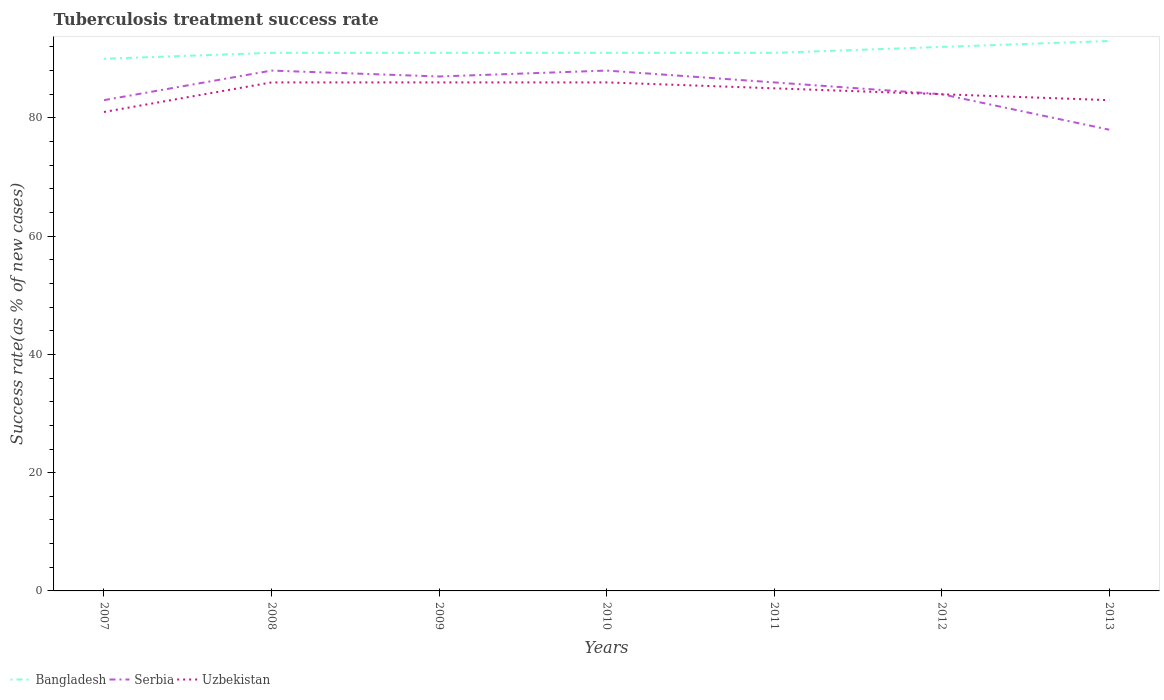What is the difference between the highest and the second highest tuberculosis treatment success rate in Uzbekistan?
Give a very brief answer. 5. Is the tuberculosis treatment success rate in Serbia strictly greater than the tuberculosis treatment success rate in Bangladesh over the years?
Provide a succinct answer. Yes. How many years are there in the graph?
Provide a short and direct response. 7. Does the graph contain any zero values?
Ensure brevity in your answer.  No. How many legend labels are there?
Provide a short and direct response. 3. What is the title of the graph?
Provide a short and direct response. Tuberculosis treatment success rate. What is the label or title of the Y-axis?
Make the answer very short. Success rate(as % of new cases). What is the Success rate(as % of new cases) in Bangladesh in 2007?
Offer a very short reply. 90. What is the Success rate(as % of new cases) in Bangladesh in 2008?
Your answer should be very brief. 91. What is the Success rate(as % of new cases) of Uzbekistan in 2008?
Your response must be concise. 86. What is the Success rate(as % of new cases) of Bangladesh in 2009?
Ensure brevity in your answer.  91. What is the Success rate(as % of new cases) in Serbia in 2009?
Offer a very short reply. 87. What is the Success rate(as % of new cases) of Uzbekistan in 2009?
Ensure brevity in your answer.  86. What is the Success rate(as % of new cases) of Bangladesh in 2010?
Provide a short and direct response. 91. What is the Success rate(as % of new cases) of Serbia in 2010?
Your answer should be compact. 88. What is the Success rate(as % of new cases) in Uzbekistan in 2010?
Provide a short and direct response. 86. What is the Success rate(as % of new cases) in Bangladesh in 2011?
Ensure brevity in your answer.  91. What is the Success rate(as % of new cases) in Serbia in 2011?
Make the answer very short. 86. What is the Success rate(as % of new cases) in Bangladesh in 2012?
Your answer should be compact. 92. What is the Success rate(as % of new cases) in Serbia in 2012?
Make the answer very short. 84. What is the Success rate(as % of new cases) of Bangladesh in 2013?
Keep it short and to the point. 93. What is the Success rate(as % of new cases) in Uzbekistan in 2013?
Offer a terse response. 83. Across all years, what is the maximum Success rate(as % of new cases) in Bangladesh?
Offer a terse response. 93. Across all years, what is the maximum Success rate(as % of new cases) of Uzbekistan?
Ensure brevity in your answer.  86. Across all years, what is the minimum Success rate(as % of new cases) of Bangladesh?
Your response must be concise. 90. Across all years, what is the minimum Success rate(as % of new cases) in Serbia?
Provide a short and direct response. 78. Across all years, what is the minimum Success rate(as % of new cases) of Uzbekistan?
Offer a terse response. 81. What is the total Success rate(as % of new cases) in Bangladesh in the graph?
Ensure brevity in your answer.  639. What is the total Success rate(as % of new cases) of Serbia in the graph?
Your answer should be very brief. 594. What is the total Success rate(as % of new cases) in Uzbekistan in the graph?
Give a very brief answer. 591. What is the difference between the Success rate(as % of new cases) in Bangladesh in 2007 and that in 2008?
Make the answer very short. -1. What is the difference between the Success rate(as % of new cases) of Uzbekistan in 2007 and that in 2008?
Make the answer very short. -5. What is the difference between the Success rate(as % of new cases) of Serbia in 2007 and that in 2009?
Your response must be concise. -4. What is the difference between the Success rate(as % of new cases) of Uzbekistan in 2007 and that in 2010?
Provide a succinct answer. -5. What is the difference between the Success rate(as % of new cases) of Serbia in 2007 and that in 2012?
Keep it short and to the point. -1. What is the difference between the Success rate(as % of new cases) in Uzbekistan in 2007 and that in 2012?
Provide a short and direct response. -3. What is the difference between the Success rate(as % of new cases) of Bangladesh in 2007 and that in 2013?
Provide a succinct answer. -3. What is the difference between the Success rate(as % of new cases) in Bangladesh in 2008 and that in 2010?
Keep it short and to the point. 0. What is the difference between the Success rate(as % of new cases) of Bangladesh in 2008 and that in 2011?
Your answer should be compact. 0. What is the difference between the Success rate(as % of new cases) in Serbia in 2008 and that in 2011?
Provide a short and direct response. 2. What is the difference between the Success rate(as % of new cases) of Uzbekistan in 2008 and that in 2012?
Give a very brief answer. 2. What is the difference between the Success rate(as % of new cases) of Serbia in 2008 and that in 2013?
Offer a terse response. 10. What is the difference between the Success rate(as % of new cases) in Bangladesh in 2009 and that in 2010?
Provide a short and direct response. 0. What is the difference between the Success rate(as % of new cases) of Bangladesh in 2009 and that in 2012?
Make the answer very short. -1. What is the difference between the Success rate(as % of new cases) in Serbia in 2009 and that in 2012?
Offer a terse response. 3. What is the difference between the Success rate(as % of new cases) of Bangladesh in 2009 and that in 2013?
Offer a terse response. -2. What is the difference between the Success rate(as % of new cases) in Serbia in 2009 and that in 2013?
Your answer should be compact. 9. What is the difference between the Success rate(as % of new cases) of Uzbekistan in 2009 and that in 2013?
Provide a short and direct response. 3. What is the difference between the Success rate(as % of new cases) of Serbia in 2010 and that in 2011?
Provide a succinct answer. 2. What is the difference between the Success rate(as % of new cases) of Bangladesh in 2010 and that in 2012?
Your response must be concise. -1. What is the difference between the Success rate(as % of new cases) of Serbia in 2010 and that in 2013?
Your answer should be compact. 10. What is the difference between the Success rate(as % of new cases) in Uzbekistan in 2010 and that in 2013?
Your answer should be very brief. 3. What is the difference between the Success rate(as % of new cases) in Bangladesh in 2011 and that in 2012?
Keep it short and to the point. -1. What is the difference between the Success rate(as % of new cases) in Serbia in 2011 and that in 2012?
Provide a succinct answer. 2. What is the difference between the Success rate(as % of new cases) in Serbia in 2011 and that in 2013?
Your answer should be very brief. 8. What is the difference between the Success rate(as % of new cases) in Bangladesh in 2012 and that in 2013?
Your answer should be compact. -1. What is the difference between the Success rate(as % of new cases) of Serbia in 2012 and that in 2013?
Keep it short and to the point. 6. What is the difference between the Success rate(as % of new cases) of Bangladesh in 2007 and the Success rate(as % of new cases) of Uzbekistan in 2008?
Offer a terse response. 4. What is the difference between the Success rate(as % of new cases) in Bangladesh in 2007 and the Success rate(as % of new cases) in Serbia in 2010?
Provide a short and direct response. 2. What is the difference between the Success rate(as % of new cases) in Bangladesh in 2007 and the Success rate(as % of new cases) in Uzbekistan in 2010?
Keep it short and to the point. 4. What is the difference between the Success rate(as % of new cases) in Serbia in 2007 and the Success rate(as % of new cases) in Uzbekistan in 2010?
Give a very brief answer. -3. What is the difference between the Success rate(as % of new cases) in Serbia in 2007 and the Success rate(as % of new cases) in Uzbekistan in 2012?
Your answer should be very brief. -1. What is the difference between the Success rate(as % of new cases) of Bangladesh in 2007 and the Success rate(as % of new cases) of Serbia in 2013?
Your answer should be very brief. 12. What is the difference between the Success rate(as % of new cases) of Bangladesh in 2007 and the Success rate(as % of new cases) of Uzbekistan in 2013?
Your answer should be very brief. 7. What is the difference between the Success rate(as % of new cases) in Serbia in 2007 and the Success rate(as % of new cases) in Uzbekistan in 2013?
Ensure brevity in your answer.  0. What is the difference between the Success rate(as % of new cases) in Bangladesh in 2008 and the Success rate(as % of new cases) in Uzbekistan in 2009?
Make the answer very short. 5. What is the difference between the Success rate(as % of new cases) of Bangladesh in 2008 and the Success rate(as % of new cases) of Uzbekistan in 2011?
Make the answer very short. 6. What is the difference between the Success rate(as % of new cases) in Bangladesh in 2008 and the Success rate(as % of new cases) in Serbia in 2012?
Offer a terse response. 7. What is the difference between the Success rate(as % of new cases) in Bangladesh in 2008 and the Success rate(as % of new cases) in Serbia in 2013?
Provide a succinct answer. 13. What is the difference between the Success rate(as % of new cases) in Bangladesh in 2008 and the Success rate(as % of new cases) in Uzbekistan in 2013?
Your answer should be compact. 8. What is the difference between the Success rate(as % of new cases) of Serbia in 2009 and the Success rate(as % of new cases) of Uzbekistan in 2011?
Offer a very short reply. 2. What is the difference between the Success rate(as % of new cases) in Bangladesh in 2009 and the Success rate(as % of new cases) in Serbia in 2012?
Give a very brief answer. 7. What is the difference between the Success rate(as % of new cases) in Bangladesh in 2009 and the Success rate(as % of new cases) in Serbia in 2013?
Your answer should be compact. 13. What is the difference between the Success rate(as % of new cases) in Serbia in 2009 and the Success rate(as % of new cases) in Uzbekistan in 2013?
Make the answer very short. 4. What is the difference between the Success rate(as % of new cases) in Serbia in 2010 and the Success rate(as % of new cases) in Uzbekistan in 2011?
Offer a terse response. 3. What is the difference between the Success rate(as % of new cases) in Bangladesh in 2010 and the Success rate(as % of new cases) in Uzbekistan in 2012?
Make the answer very short. 7. What is the difference between the Success rate(as % of new cases) of Serbia in 2010 and the Success rate(as % of new cases) of Uzbekistan in 2013?
Your answer should be very brief. 5. What is the difference between the Success rate(as % of new cases) in Bangladesh in 2011 and the Success rate(as % of new cases) in Serbia in 2012?
Provide a short and direct response. 7. What is the difference between the Success rate(as % of new cases) in Bangladesh in 2011 and the Success rate(as % of new cases) in Serbia in 2013?
Provide a short and direct response. 13. What is the difference between the Success rate(as % of new cases) in Serbia in 2011 and the Success rate(as % of new cases) in Uzbekistan in 2013?
Ensure brevity in your answer.  3. What is the average Success rate(as % of new cases) of Bangladesh per year?
Your answer should be very brief. 91.29. What is the average Success rate(as % of new cases) in Serbia per year?
Your answer should be compact. 84.86. What is the average Success rate(as % of new cases) of Uzbekistan per year?
Provide a succinct answer. 84.43. In the year 2007, what is the difference between the Success rate(as % of new cases) in Bangladesh and Success rate(as % of new cases) in Serbia?
Make the answer very short. 7. In the year 2007, what is the difference between the Success rate(as % of new cases) in Serbia and Success rate(as % of new cases) in Uzbekistan?
Provide a short and direct response. 2. In the year 2008, what is the difference between the Success rate(as % of new cases) of Bangladesh and Success rate(as % of new cases) of Serbia?
Your answer should be compact. 3. In the year 2009, what is the difference between the Success rate(as % of new cases) of Bangladesh and Success rate(as % of new cases) of Uzbekistan?
Ensure brevity in your answer.  5. In the year 2009, what is the difference between the Success rate(as % of new cases) of Serbia and Success rate(as % of new cases) of Uzbekistan?
Offer a very short reply. 1. In the year 2010, what is the difference between the Success rate(as % of new cases) in Bangladesh and Success rate(as % of new cases) in Serbia?
Your response must be concise. 3. In the year 2010, what is the difference between the Success rate(as % of new cases) of Serbia and Success rate(as % of new cases) of Uzbekistan?
Offer a very short reply. 2. In the year 2011, what is the difference between the Success rate(as % of new cases) in Bangladesh and Success rate(as % of new cases) in Serbia?
Offer a very short reply. 5. In the year 2011, what is the difference between the Success rate(as % of new cases) in Bangladesh and Success rate(as % of new cases) in Uzbekistan?
Ensure brevity in your answer.  6. In the year 2011, what is the difference between the Success rate(as % of new cases) in Serbia and Success rate(as % of new cases) in Uzbekistan?
Provide a succinct answer. 1. In the year 2012, what is the difference between the Success rate(as % of new cases) of Bangladesh and Success rate(as % of new cases) of Serbia?
Keep it short and to the point. 8. In the year 2012, what is the difference between the Success rate(as % of new cases) in Serbia and Success rate(as % of new cases) in Uzbekistan?
Offer a very short reply. 0. In the year 2013, what is the difference between the Success rate(as % of new cases) in Bangladesh and Success rate(as % of new cases) in Serbia?
Your answer should be very brief. 15. In the year 2013, what is the difference between the Success rate(as % of new cases) in Bangladesh and Success rate(as % of new cases) in Uzbekistan?
Give a very brief answer. 10. In the year 2013, what is the difference between the Success rate(as % of new cases) in Serbia and Success rate(as % of new cases) in Uzbekistan?
Your response must be concise. -5. What is the ratio of the Success rate(as % of new cases) in Bangladesh in 2007 to that in 2008?
Make the answer very short. 0.99. What is the ratio of the Success rate(as % of new cases) of Serbia in 2007 to that in 2008?
Keep it short and to the point. 0.94. What is the ratio of the Success rate(as % of new cases) of Uzbekistan in 2007 to that in 2008?
Offer a very short reply. 0.94. What is the ratio of the Success rate(as % of new cases) in Serbia in 2007 to that in 2009?
Keep it short and to the point. 0.95. What is the ratio of the Success rate(as % of new cases) in Uzbekistan in 2007 to that in 2009?
Provide a succinct answer. 0.94. What is the ratio of the Success rate(as % of new cases) of Serbia in 2007 to that in 2010?
Make the answer very short. 0.94. What is the ratio of the Success rate(as % of new cases) in Uzbekistan in 2007 to that in 2010?
Keep it short and to the point. 0.94. What is the ratio of the Success rate(as % of new cases) in Serbia in 2007 to that in 2011?
Your answer should be very brief. 0.97. What is the ratio of the Success rate(as % of new cases) in Uzbekistan in 2007 to that in 2011?
Offer a very short reply. 0.95. What is the ratio of the Success rate(as % of new cases) of Bangladesh in 2007 to that in 2012?
Provide a short and direct response. 0.98. What is the ratio of the Success rate(as % of new cases) of Serbia in 2007 to that in 2012?
Give a very brief answer. 0.99. What is the ratio of the Success rate(as % of new cases) in Uzbekistan in 2007 to that in 2012?
Your answer should be compact. 0.96. What is the ratio of the Success rate(as % of new cases) in Serbia in 2007 to that in 2013?
Keep it short and to the point. 1.06. What is the ratio of the Success rate(as % of new cases) of Uzbekistan in 2007 to that in 2013?
Your answer should be very brief. 0.98. What is the ratio of the Success rate(as % of new cases) in Serbia in 2008 to that in 2009?
Your response must be concise. 1.01. What is the ratio of the Success rate(as % of new cases) in Uzbekistan in 2008 to that in 2009?
Your response must be concise. 1. What is the ratio of the Success rate(as % of new cases) of Bangladesh in 2008 to that in 2010?
Provide a succinct answer. 1. What is the ratio of the Success rate(as % of new cases) in Serbia in 2008 to that in 2010?
Your answer should be compact. 1. What is the ratio of the Success rate(as % of new cases) of Bangladesh in 2008 to that in 2011?
Your answer should be compact. 1. What is the ratio of the Success rate(as % of new cases) of Serbia in 2008 to that in 2011?
Offer a terse response. 1.02. What is the ratio of the Success rate(as % of new cases) in Uzbekistan in 2008 to that in 2011?
Offer a terse response. 1.01. What is the ratio of the Success rate(as % of new cases) of Bangladesh in 2008 to that in 2012?
Your answer should be compact. 0.99. What is the ratio of the Success rate(as % of new cases) of Serbia in 2008 to that in 2012?
Ensure brevity in your answer.  1.05. What is the ratio of the Success rate(as % of new cases) of Uzbekistan in 2008 to that in 2012?
Make the answer very short. 1.02. What is the ratio of the Success rate(as % of new cases) of Bangladesh in 2008 to that in 2013?
Ensure brevity in your answer.  0.98. What is the ratio of the Success rate(as % of new cases) in Serbia in 2008 to that in 2013?
Your answer should be very brief. 1.13. What is the ratio of the Success rate(as % of new cases) of Uzbekistan in 2008 to that in 2013?
Provide a short and direct response. 1.04. What is the ratio of the Success rate(as % of new cases) in Serbia in 2009 to that in 2010?
Offer a terse response. 0.99. What is the ratio of the Success rate(as % of new cases) of Serbia in 2009 to that in 2011?
Provide a succinct answer. 1.01. What is the ratio of the Success rate(as % of new cases) of Uzbekistan in 2009 to that in 2011?
Provide a short and direct response. 1.01. What is the ratio of the Success rate(as % of new cases) of Serbia in 2009 to that in 2012?
Offer a terse response. 1.04. What is the ratio of the Success rate(as % of new cases) in Uzbekistan in 2009 to that in 2012?
Ensure brevity in your answer.  1.02. What is the ratio of the Success rate(as % of new cases) in Bangladesh in 2009 to that in 2013?
Offer a terse response. 0.98. What is the ratio of the Success rate(as % of new cases) in Serbia in 2009 to that in 2013?
Give a very brief answer. 1.12. What is the ratio of the Success rate(as % of new cases) of Uzbekistan in 2009 to that in 2013?
Ensure brevity in your answer.  1.04. What is the ratio of the Success rate(as % of new cases) in Bangladesh in 2010 to that in 2011?
Offer a terse response. 1. What is the ratio of the Success rate(as % of new cases) in Serbia in 2010 to that in 2011?
Ensure brevity in your answer.  1.02. What is the ratio of the Success rate(as % of new cases) in Uzbekistan in 2010 to that in 2011?
Provide a short and direct response. 1.01. What is the ratio of the Success rate(as % of new cases) in Bangladesh in 2010 to that in 2012?
Provide a succinct answer. 0.99. What is the ratio of the Success rate(as % of new cases) in Serbia in 2010 to that in 2012?
Ensure brevity in your answer.  1.05. What is the ratio of the Success rate(as % of new cases) in Uzbekistan in 2010 to that in 2012?
Provide a short and direct response. 1.02. What is the ratio of the Success rate(as % of new cases) in Bangladesh in 2010 to that in 2013?
Offer a very short reply. 0.98. What is the ratio of the Success rate(as % of new cases) in Serbia in 2010 to that in 2013?
Make the answer very short. 1.13. What is the ratio of the Success rate(as % of new cases) of Uzbekistan in 2010 to that in 2013?
Your response must be concise. 1.04. What is the ratio of the Success rate(as % of new cases) of Bangladesh in 2011 to that in 2012?
Your answer should be compact. 0.99. What is the ratio of the Success rate(as % of new cases) in Serbia in 2011 to that in 2012?
Ensure brevity in your answer.  1.02. What is the ratio of the Success rate(as % of new cases) of Uzbekistan in 2011 to that in 2012?
Make the answer very short. 1.01. What is the ratio of the Success rate(as % of new cases) of Bangladesh in 2011 to that in 2013?
Your response must be concise. 0.98. What is the ratio of the Success rate(as % of new cases) in Serbia in 2011 to that in 2013?
Ensure brevity in your answer.  1.1. What is the ratio of the Success rate(as % of new cases) of Uzbekistan in 2011 to that in 2013?
Give a very brief answer. 1.02. What is the ratio of the Success rate(as % of new cases) of Serbia in 2012 to that in 2013?
Provide a succinct answer. 1.08. What is the difference between the highest and the second highest Success rate(as % of new cases) of Bangladesh?
Make the answer very short. 1. What is the difference between the highest and the second highest Success rate(as % of new cases) of Serbia?
Your answer should be very brief. 0. What is the difference between the highest and the lowest Success rate(as % of new cases) in Uzbekistan?
Your answer should be very brief. 5. 